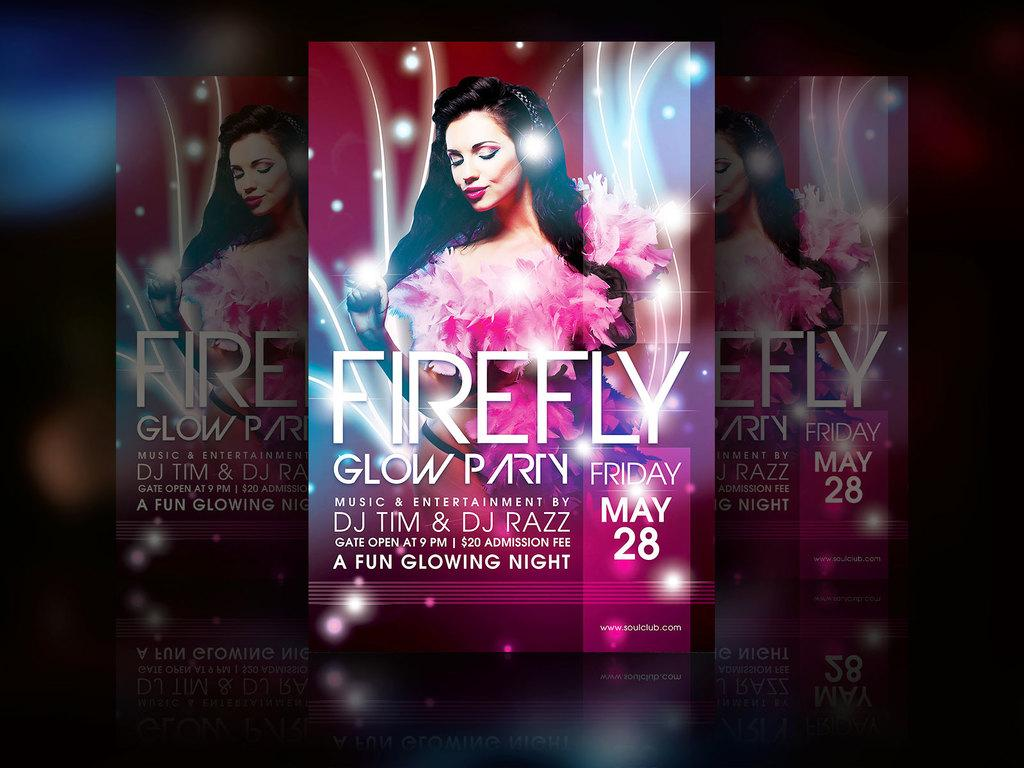<image>
Describe the image concisely. An advertisement for Firefly Glow Party on Friday May 28th. 